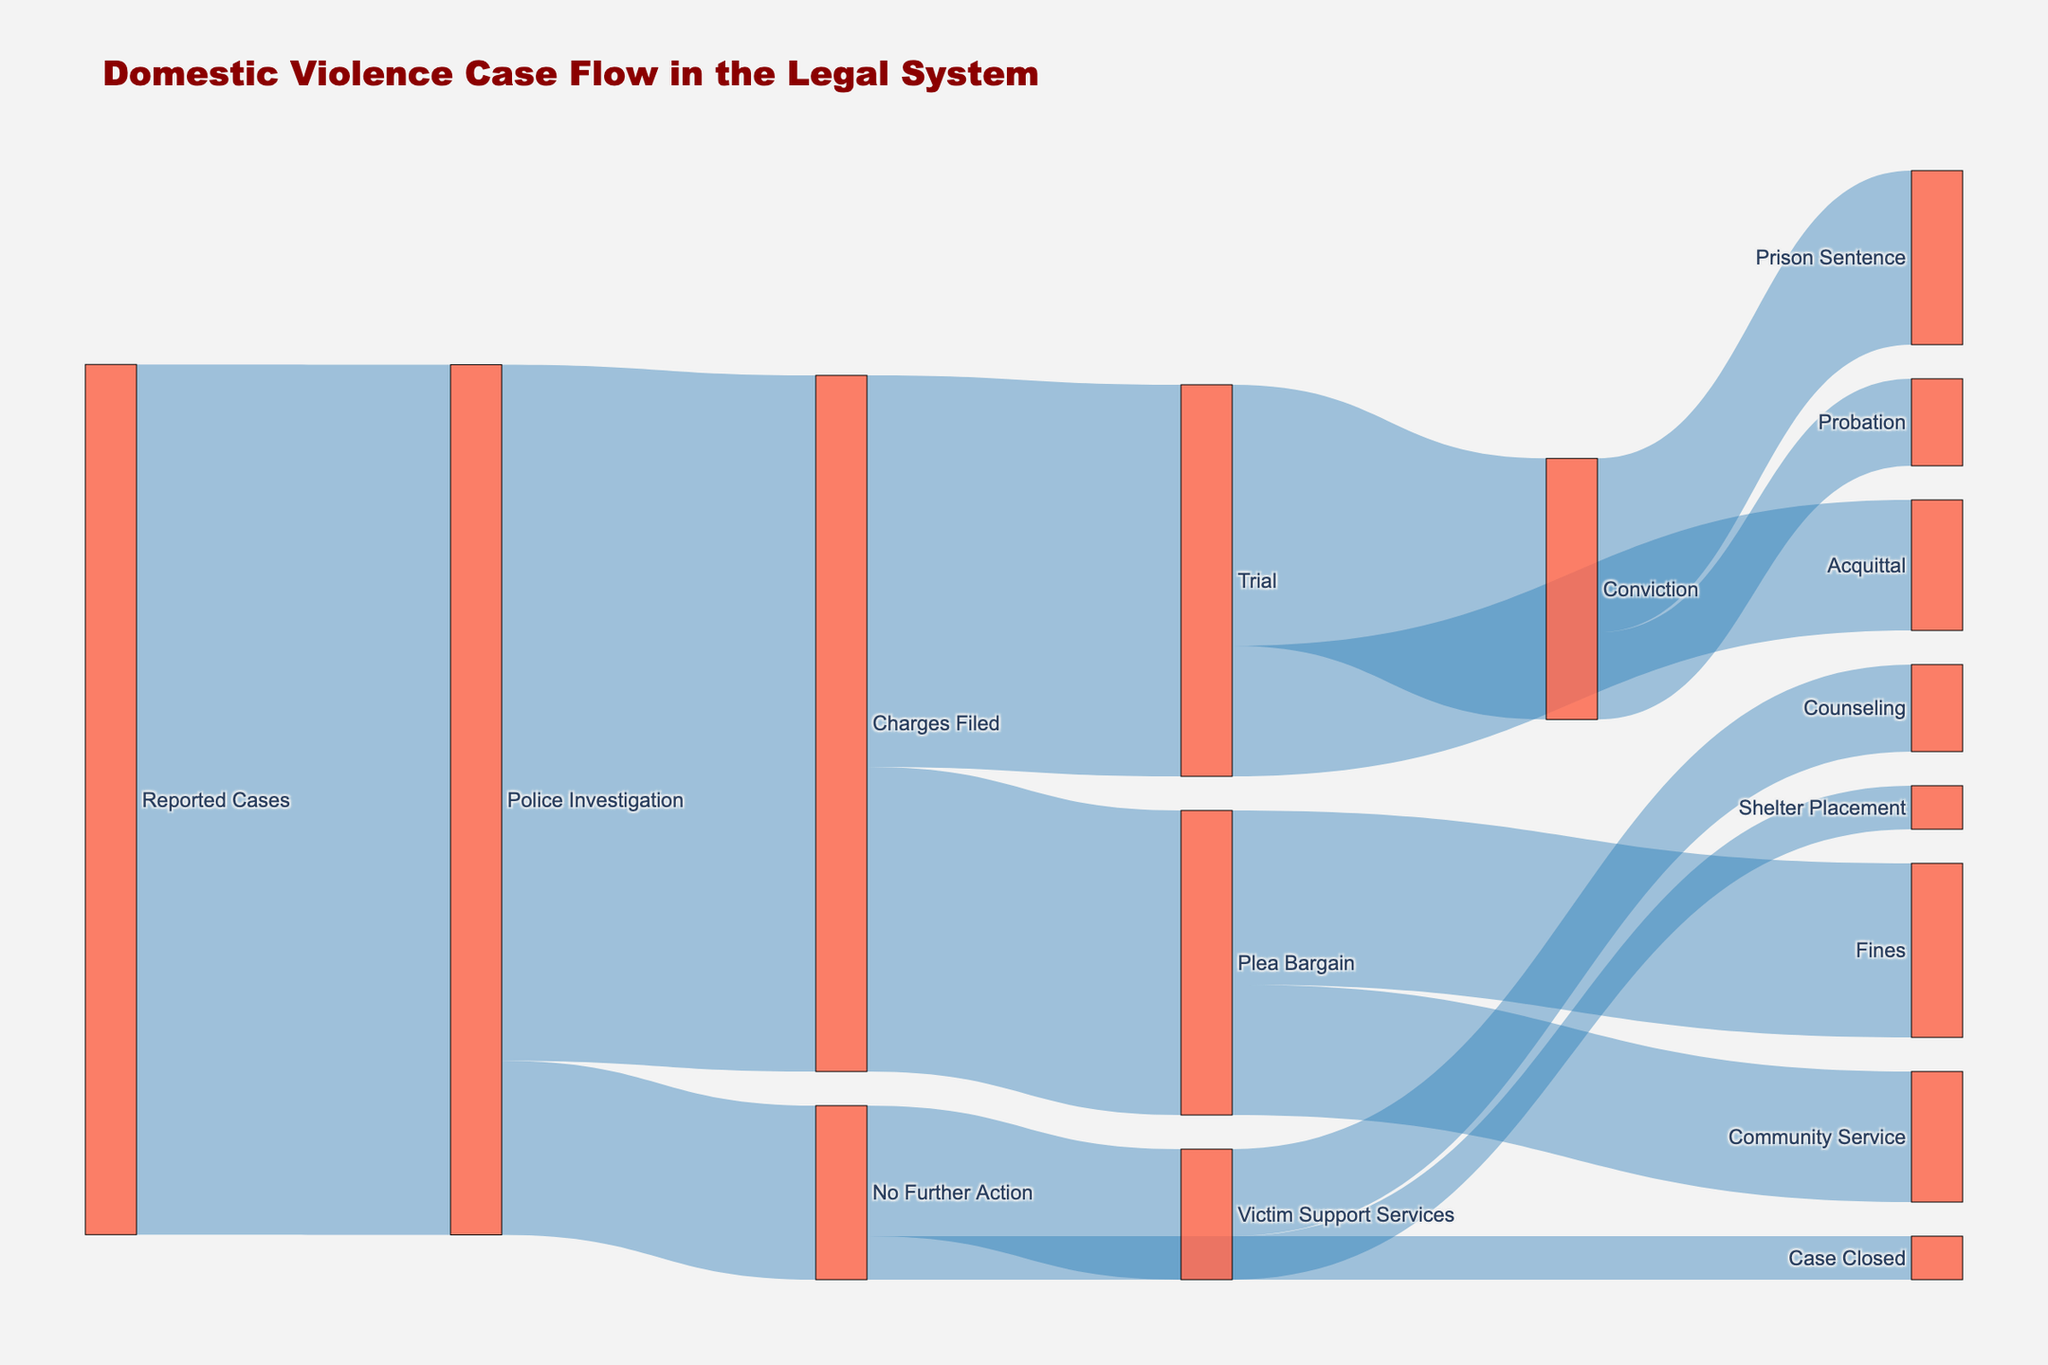What is the title of the diagram? The title of the diagram is usually displayed at the top of the plot and directly states what the diagram is about.
Answer: "Domestic Violence Case Flow in the Legal System" How many reported cases of domestic violence enter police investigation? The number of cases entering the police investigation is shown as the flow from "Reported Cases" to "Police Investigation."
Answer: 10,000 What are the possible outcomes after a police investigation? You can follow the flow lines from "Police Investigation" to see the outcomes: "No Further Action" and "Charges Filed."
Answer: No Further Action, Charges Filed How many cases result in no further action from the police investigation? Follow the flow from "Police Investigation" to "No Further Action" and check the value associated with it.
Answer: 2,000 What is the total number of cases that go to trial? Follow the flow from "Police Investigation" to "Charges Filed" and then sum up the value going from "Charges Filed" to "Trial."
Answer: 4,500 How many convictions are secured from cases that go to trial? Look at the flow from "Trial" to "Conviction" to see how many end in a conviction.
Answer: 3,000 What is the outcome of the largest number of plea bargains? Trace the flow from "Plea Bargain" to its outcomes and compare their values to identify the largest.
Answer: Fines Compare the number of prison sentences and probation. Which one has a higher value? Compare the flows from "Conviction" to "Prison Sentence" and "Probation" to see which one has the higher value.
Answer: Prison Sentence Out of the cases that see no further action, how many receive victim support services? Follow the flow from "No Further Action" to "Victim Support Services" to determine the number.
Answer: 1,500 What is the total number of reported cases that either result in victim support services or the case being closed without further action? Add the values of the flows from "No Further Action" to "Victim Support Services" and "Case Closed."
Answer: 2,000 